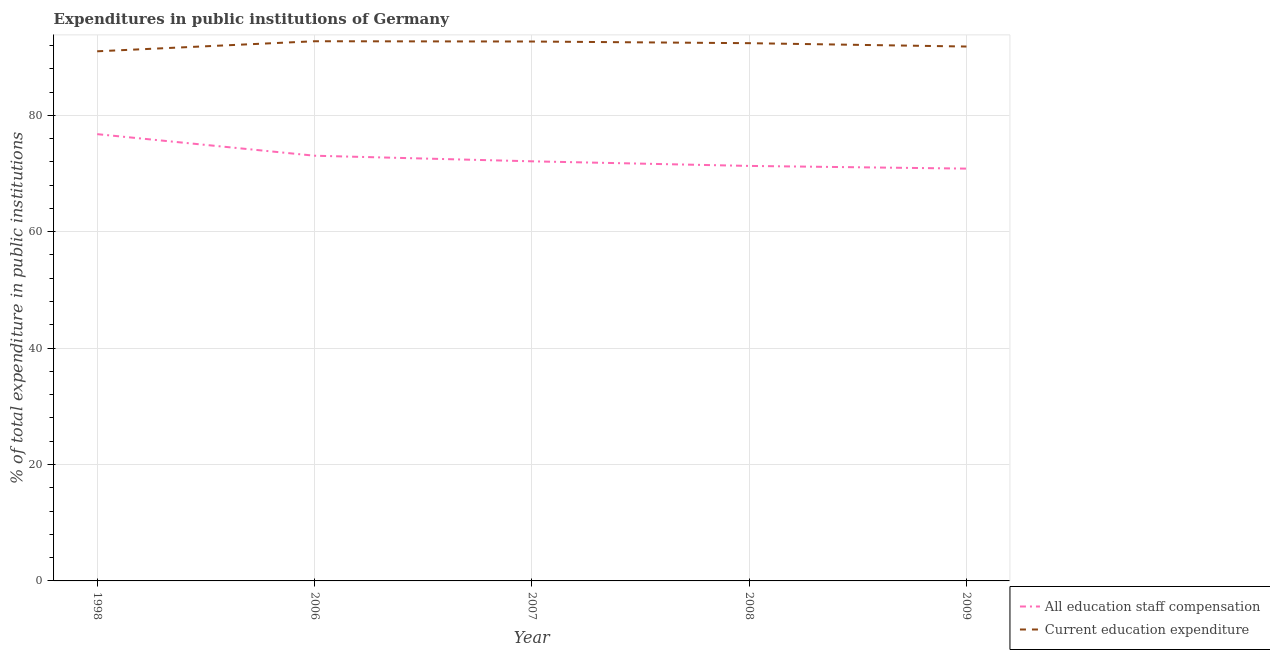Is the number of lines equal to the number of legend labels?
Keep it short and to the point. Yes. What is the expenditure in education in 2008?
Your response must be concise. 92.39. Across all years, what is the maximum expenditure in staff compensation?
Your response must be concise. 76.76. Across all years, what is the minimum expenditure in education?
Your answer should be very brief. 91. What is the total expenditure in staff compensation in the graph?
Offer a terse response. 364.07. What is the difference between the expenditure in education in 1998 and that in 2009?
Ensure brevity in your answer.  -0.82. What is the difference between the expenditure in education in 1998 and the expenditure in staff compensation in 2006?
Make the answer very short. 17.94. What is the average expenditure in staff compensation per year?
Your response must be concise. 72.81. In the year 1998, what is the difference between the expenditure in staff compensation and expenditure in education?
Make the answer very short. -14.23. What is the ratio of the expenditure in education in 2007 to that in 2009?
Your answer should be very brief. 1.01. What is the difference between the highest and the second highest expenditure in staff compensation?
Your answer should be compact. 3.71. What is the difference between the highest and the lowest expenditure in education?
Ensure brevity in your answer.  1.73. In how many years, is the expenditure in education greater than the average expenditure in education taken over all years?
Provide a succinct answer. 3. Is the sum of the expenditure in staff compensation in 1998 and 2009 greater than the maximum expenditure in education across all years?
Make the answer very short. Yes. Does the expenditure in staff compensation monotonically increase over the years?
Make the answer very short. No. Is the expenditure in education strictly greater than the expenditure in staff compensation over the years?
Provide a short and direct response. Yes. How many lines are there?
Your answer should be very brief. 2. Where does the legend appear in the graph?
Offer a terse response. Bottom right. How are the legend labels stacked?
Provide a short and direct response. Vertical. What is the title of the graph?
Your response must be concise. Expenditures in public institutions of Germany. Does "Official aid received" appear as one of the legend labels in the graph?
Offer a terse response. No. What is the label or title of the Y-axis?
Provide a short and direct response. % of total expenditure in public institutions. What is the % of total expenditure in public institutions in All education staff compensation in 1998?
Your answer should be very brief. 76.76. What is the % of total expenditure in public institutions in Current education expenditure in 1998?
Make the answer very short. 91. What is the % of total expenditure in public institutions of All education staff compensation in 2006?
Keep it short and to the point. 73.06. What is the % of total expenditure in public institutions in Current education expenditure in 2006?
Provide a short and direct response. 92.73. What is the % of total expenditure in public institutions in All education staff compensation in 2007?
Provide a short and direct response. 72.1. What is the % of total expenditure in public institutions of Current education expenditure in 2007?
Your response must be concise. 92.68. What is the % of total expenditure in public institutions of All education staff compensation in 2008?
Your answer should be compact. 71.3. What is the % of total expenditure in public institutions in Current education expenditure in 2008?
Give a very brief answer. 92.39. What is the % of total expenditure in public institutions of All education staff compensation in 2009?
Provide a succinct answer. 70.84. What is the % of total expenditure in public institutions in Current education expenditure in 2009?
Offer a very short reply. 91.82. Across all years, what is the maximum % of total expenditure in public institutions of All education staff compensation?
Provide a short and direct response. 76.76. Across all years, what is the maximum % of total expenditure in public institutions of Current education expenditure?
Keep it short and to the point. 92.73. Across all years, what is the minimum % of total expenditure in public institutions of All education staff compensation?
Offer a very short reply. 70.84. Across all years, what is the minimum % of total expenditure in public institutions of Current education expenditure?
Make the answer very short. 91. What is the total % of total expenditure in public institutions in All education staff compensation in the graph?
Provide a succinct answer. 364.07. What is the total % of total expenditure in public institutions of Current education expenditure in the graph?
Give a very brief answer. 460.62. What is the difference between the % of total expenditure in public institutions in All education staff compensation in 1998 and that in 2006?
Give a very brief answer. 3.71. What is the difference between the % of total expenditure in public institutions of Current education expenditure in 1998 and that in 2006?
Your answer should be very brief. -1.73. What is the difference between the % of total expenditure in public institutions in All education staff compensation in 1998 and that in 2007?
Offer a terse response. 4.67. What is the difference between the % of total expenditure in public institutions of Current education expenditure in 1998 and that in 2007?
Make the answer very short. -1.68. What is the difference between the % of total expenditure in public institutions in All education staff compensation in 1998 and that in 2008?
Your answer should be compact. 5.46. What is the difference between the % of total expenditure in public institutions of Current education expenditure in 1998 and that in 2008?
Provide a short and direct response. -1.4. What is the difference between the % of total expenditure in public institutions of All education staff compensation in 1998 and that in 2009?
Your answer should be compact. 5.92. What is the difference between the % of total expenditure in public institutions in Current education expenditure in 1998 and that in 2009?
Give a very brief answer. -0.82. What is the difference between the % of total expenditure in public institutions in All education staff compensation in 2006 and that in 2007?
Your answer should be very brief. 0.96. What is the difference between the % of total expenditure in public institutions in Current education expenditure in 2006 and that in 2007?
Your response must be concise. 0.05. What is the difference between the % of total expenditure in public institutions of All education staff compensation in 2006 and that in 2008?
Your response must be concise. 1.75. What is the difference between the % of total expenditure in public institutions in Current education expenditure in 2006 and that in 2008?
Keep it short and to the point. 0.33. What is the difference between the % of total expenditure in public institutions in All education staff compensation in 2006 and that in 2009?
Your answer should be compact. 2.22. What is the difference between the % of total expenditure in public institutions of Current education expenditure in 2006 and that in 2009?
Your answer should be compact. 0.91. What is the difference between the % of total expenditure in public institutions in All education staff compensation in 2007 and that in 2008?
Provide a short and direct response. 0.79. What is the difference between the % of total expenditure in public institutions in Current education expenditure in 2007 and that in 2008?
Your response must be concise. 0.29. What is the difference between the % of total expenditure in public institutions in All education staff compensation in 2007 and that in 2009?
Your answer should be compact. 1.25. What is the difference between the % of total expenditure in public institutions of Current education expenditure in 2007 and that in 2009?
Offer a terse response. 0.86. What is the difference between the % of total expenditure in public institutions of All education staff compensation in 2008 and that in 2009?
Keep it short and to the point. 0.46. What is the difference between the % of total expenditure in public institutions of Current education expenditure in 2008 and that in 2009?
Make the answer very short. 0.58. What is the difference between the % of total expenditure in public institutions of All education staff compensation in 1998 and the % of total expenditure in public institutions of Current education expenditure in 2006?
Your answer should be compact. -15.96. What is the difference between the % of total expenditure in public institutions in All education staff compensation in 1998 and the % of total expenditure in public institutions in Current education expenditure in 2007?
Offer a terse response. -15.92. What is the difference between the % of total expenditure in public institutions in All education staff compensation in 1998 and the % of total expenditure in public institutions in Current education expenditure in 2008?
Your answer should be compact. -15.63. What is the difference between the % of total expenditure in public institutions in All education staff compensation in 1998 and the % of total expenditure in public institutions in Current education expenditure in 2009?
Offer a terse response. -15.05. What is the difference between the % of total expenditure in public institutions in All education staff compensation in 2006 and the % of total expenditure in public institutions in Current education expenditure in 2007?
Provide a succinct answer. -19.62. What is the difference between the % of total expenditure in public institutions in All education staff compensation in 2006 and the % of total expenditure in public institutions in Current education expenditure in 2008?
Your response must be concise. -19.34. What is the difference between the % of total expenditure in public institutions of All education staff compensation in 2006 and the % of total expenditure in public institutions of Current education expenditure in 2009?
Give a very brief answer. -18.76. What is the difference between the % of total expenditure in public institutions in All education staff compensation in 2007 and the % of total expenditure in public institutions in Current education expenditure in 2008?
Keep it short and to the point. -20.3. What is the difference between the % of total expenditure in public institutions of All education staff compensation in 2007 and the % of total expenditure in public institutions of Current education expenditure in 2009?
Provide a succinct answer. -19.72. What is the difference between the % of total expenditure in public institutions of All education staff compensation in 2008 and the % of total expenditure in public institutions of Current education expenditure in 2009?
Your answer should be compact. -20.51. What is the average % of total expenditure in public institutions of All education staff compensation per year?
Offer a terse response. 72.81. What is the average % of total expenditure in public institutions in Current education expenditure per year?
Your response must be concise. 92.12. In the year 1998, what is the difference between the % of total expenditure in public institutions of All education staff compensation and % of total expenditure in public institutions of Current education expenditure?
Offer a very short reply. -14.23. In the year 2006, what is the difference between the % of total expenditure in public institutions of All education staff compensation and % of total expenditure in public institutions of Current education expenditure?
Make the answer very short. -19.67. In the year 2007, what is the difference between the % of total expenditure in public institutions of All education staff compensation and % of total expenditure in public institutions of Current education expenditure?
Your answer should be compact. -20.58. In the year 2008, what is the difference between the % of total expenditure in public institutions of All education staff compensation and % of total expenditure in public institutions of Current education expenditure?
Offer a terse response. -21.09. In the year 2009, what is the difference between the % of total expenditure in public institutions in All education staff compensation and % of total expenditure in public institutions in Current education expenditure?
Offer a terse response. -20.98. What is the ratio of the % of total expenditure in public institutions of All education staff compensation in 1998 to that in 2006?
Your answer should be compact. 1.05. What is the ratio of the % of total expenditure in public institutions in Current education expenditure in 1998 to that in 2006?
Your answer should be compact. 0.98. What is the ratio of the % of total expenditure in public institutions in All education staff compensation in 1998 to that in 2007?
Make the answer very short. 1.06. What is the ratio of the % of total expenditure in public institutions of Current education expenditure in 1998 to that in 2007?
Keep it short and to the point. 0.98. What is the ratio of the % of total expenditure in public institutions in All education staff compensation in 1998 to that in 2008?
Offer a terse response. 1.08. What is the ratio of the % of total expenditure in public institutions in Current education expenditure in 1998 to that in 2008?
Your response must be concise. 0.98. What is the ratio of the % of total expenditure in public institutions of All education staff compensation in 1998 to that in 2009?
Your response must be concise. 1.08. What is the ratio of the % of total expenditure in public institutions of Current education expenditure in 1998 to that in 2009?
Provide a short and direct response. 0.99. What is the ratio of the % of total expenditure in public institutions in All education staff compensation in 2006 to that in 2007?
Make the answer very short. 1.01. What is the ratio of the % of total expenditure in public institutions in Current education expenditure in 2006 to that in 2007?
Offer a very short reply. 1. What is the ratio of the % of total expenditure in public institutions of All education staff compensation in 2006 to that in 2008?
Make the answer very short. 1.02. What is the ratio of the % of total expenditure in public institutions of Current education expenditure in 2006 to that in 2008?
Your response must be concise. 1. What is the ratio of the % of total expenditure in public institutions in All education staff compensation in 2006 to that in 2009?
Provide a short and direct response. 1.03. What is the ratio of the % of total expenditure in public institutions of Current education expenditure in 2006 to that in 2009?
Your response must be concise. 1.01. What is the ratio of the % of total expenditure in public institutions in All education staff compensation in 2007 to that in 2008?
Your answer should be compact. 1.01. What is the ratio of the % of total expenditure in public institutions in All education staff compensation in 2007 to that in 2009?
Make the answer very short. 1.02. What is the ratio of the % of total expenditure in public institutions of Current education expenditure in 2007 to that in 2009?
Make the answer very short. 1.01. What is the ratio of the % of total expenditure in public institutions of Current education expenditure in 2008 to that in 2009?
Your response must be concise. 1.01. What is the difference between the highest and the second highest % of total expenditure in public institutions of All education staff compensation?
Your answer should be very brief. 3.71. What is the difference between the highest and the second highest % of total expenditure in public institutions in Current education expenditure?
Provide a succinct answer. 0.05. What is the difference between the highest and the lowest % of total expenditure in public institutions in All education staff compensation?
Give a very brief answer. 5.92. What is the difference between the highest and the lowest % of total expenditure in public institutions of Current education expenditure?
Your answer should be very brief. 1.73. 